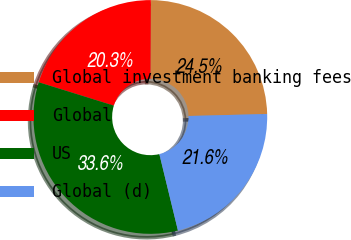<chart> <loc_0><loc_0><loc_500><loc_500><pie_chart><fcel>Global investment banking fees<fcel>Global<fcel>US<fcel>Global (d)<nl><fcel>24.52%<fcel>20.28%<fcel>33.6%<fcel>21.61%<nl></chart> 